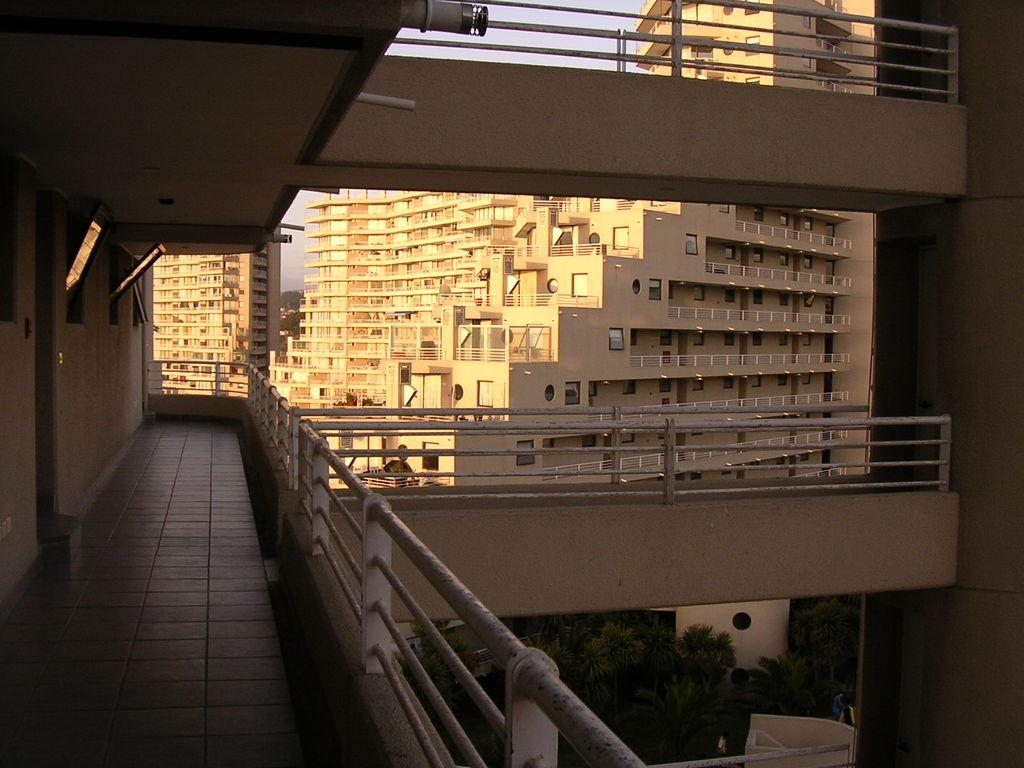What type of outdoor space is visible in the image? There is a balcony in the image. Where is the door located in the image? The door is on the left side of the image. What can be seen in the distance in the image? There are trees visible in the image. What type of structures are present in the image? There are buildings with windows in the image. What is the condition of the sky in the image? The sky is clear in the image. What type of punishment is being administered on the balcony in the image? There is no punishment being administered in the image; it only shows a balcony, a door, trees, buildings, and a clear sky. Can you see a whip being used on the balcony in the image? No, there is no whip or any indication of punishment in the image. 